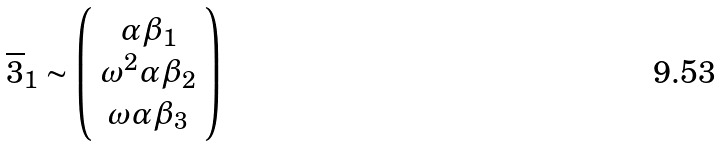Convert formula to latex. <formula><loc_0><loc_0><loc_500><loc_500>\overline { 3 } _ { 1 } \sim \left ( \begin{array} { c } \alpha \beta _ { 1 } \\ \omega ^ { 2 } \alpha \beta _ { 2 } \\ \omega \alpha \beta _ { 3 } \end{array} \right )</formula> 